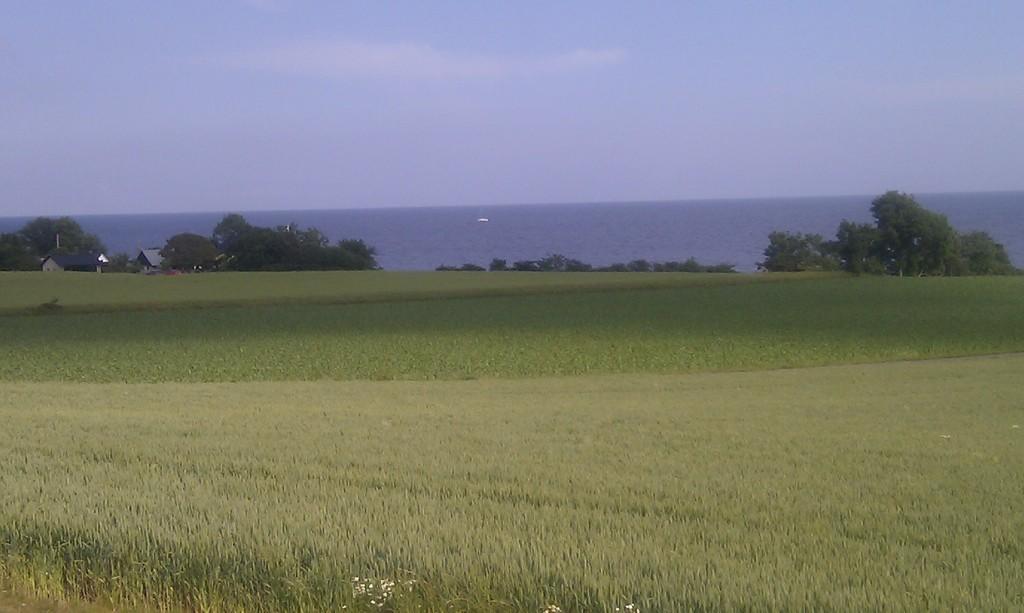Please provide a concise description of this image. In this image we can see the sea. We can see the sky in the image. There are few houses at the left side of the image. There are few agricultural fields in the image. There are many trees in the image. 